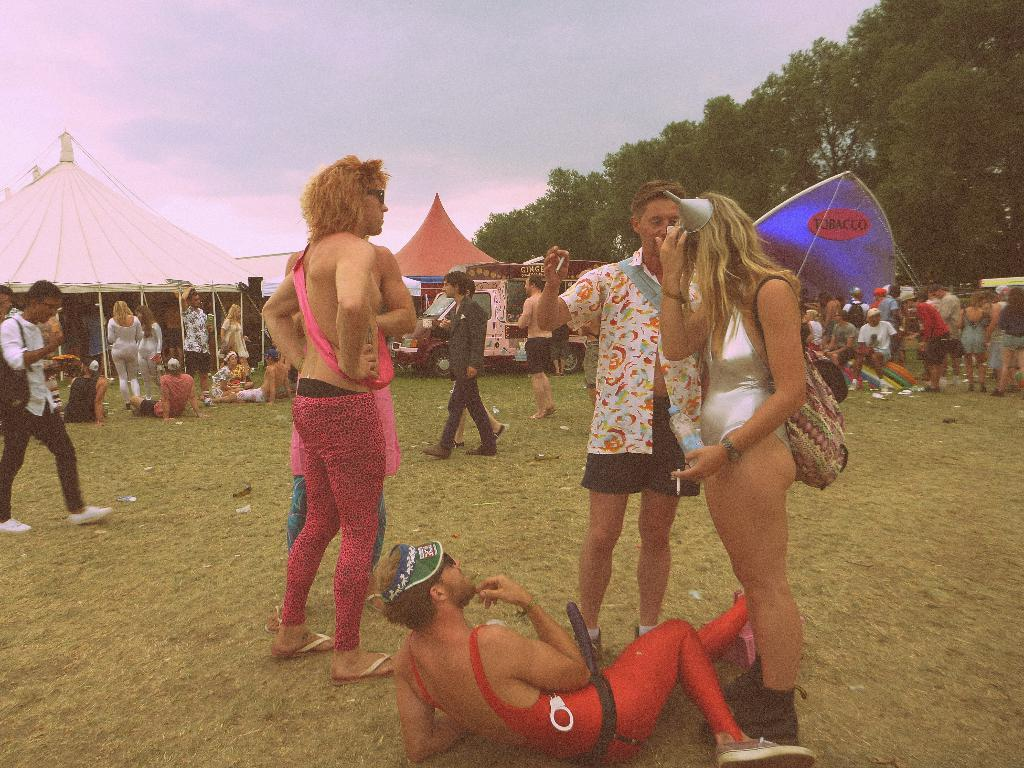How many people can be seen in the image? There are many people in the image. What type of terrain is visible in the image? There is grass in the image. What type of temporary shelters are present in the image? There are tents in the image. What mode of transportation is visible in the image? There is a vehicle in the image. What type of vegetation is on the right side of the image? There are trees on the right side of the image. What part of the natural environment is visible in the image? The sky is visible in the image. Can you tell me how many balls are being juggled by the people in the image? There is no indication in the image that anyone is juggling balls. What type of church is visible in the image? There is no church present in the image. 